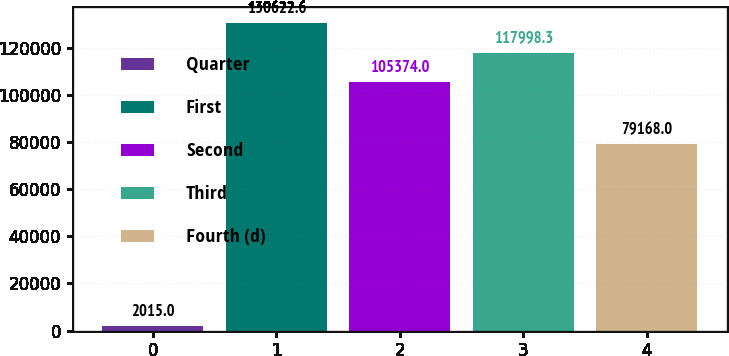Convert chart to OTSL. <chart><loc_0><loc_0><loc_500><loc_500><bar_chart><fcel>Quarter<fcel>First<fcel>Second<fcel>Third<fcel>Fourth (d)<nl><fcel>2015<fcel>130623<fcel>105374<fcel>117998<fcel>79168<nl></chart> 